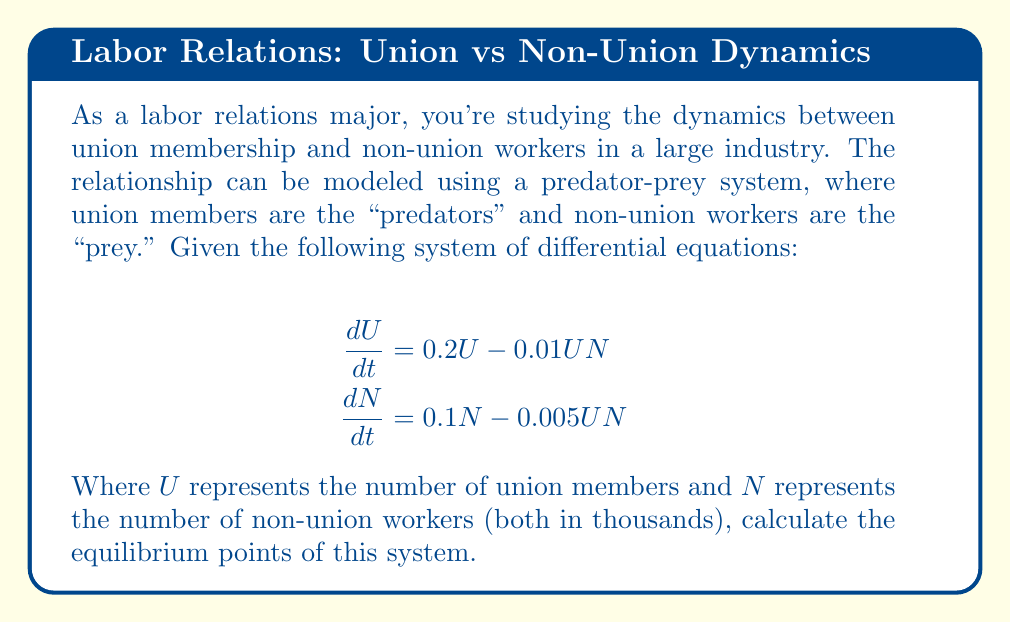Can you answer this question? To find the equilibrium points, we need to set both equations equal to zero and solve for $U$ and $N$:

1) Set $\frac{dU}{dt} = 0$ and $\frac{dN}{dt} = 0$:

   $$\begin{align}
   0 &= 0.2U - 0.01UN \\
   0 &= 0.1N - 0.005UN
   \end{align}$$

2) From the first equation:
   $0.2U - 0.01UN = 0$
   $U(0.2 - 0.01N) = 0$

   This gives us two possibilities: $U = 0$ or $0.2 - 0.01N = 0$

3) If $U = 0$, from the second equation:
   $0 = 0.1N - 0.005(0)N = 0.1N$
   This gives us $N = 0$

   So, one equilibrium point is $(0, 0)$

4) If $0.2 - 0.01N = 0$, then:
   $0.2 = 0.01N$
   $N = 20$

5) Substitute $N = 20$ into the second equation:
   $0 = 0.1(20) - 0.005U(20)$
   $2 = 0.1U$
   $U = 20$

   This gives us the second equilibrium point $(20, 20)$

Therefore, the system has two equilibrium points: $(0, 0)$ and $(20, 20)$.
Answer: $(0, 0)$ and $(20, 20)$ 